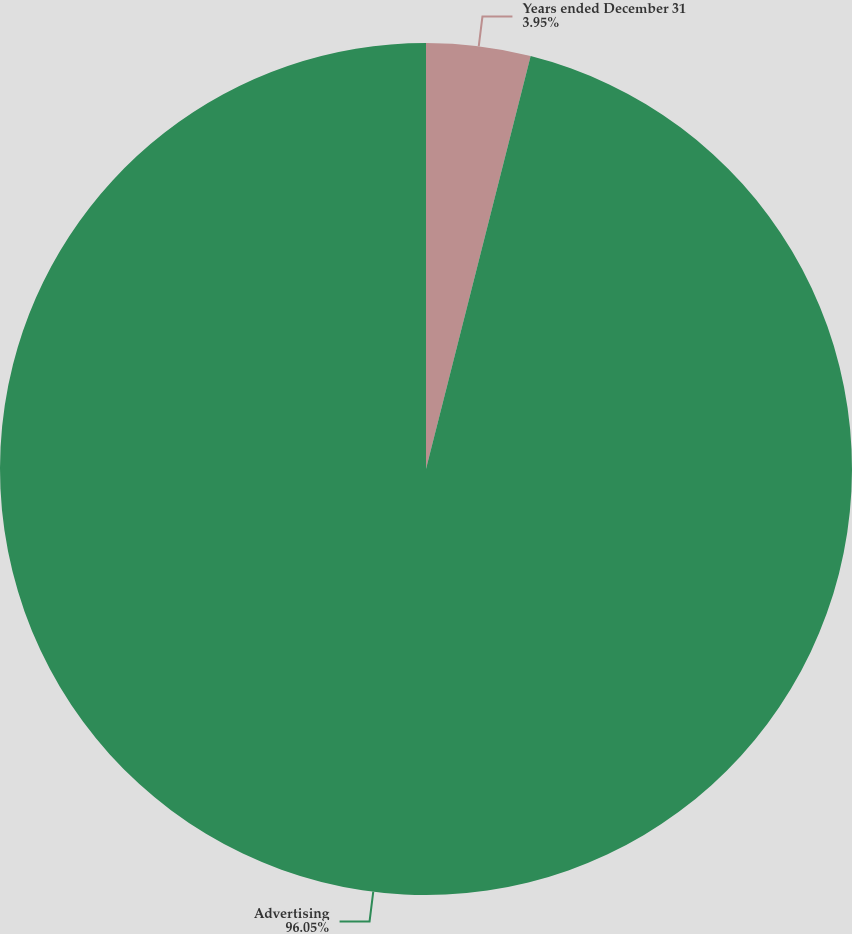Convert chart to OTSL. <chart><loc_0><loc_0><loc_500><loc_500><pie_chart><fcel>Years ended December 31<fcel>Advertising<nl><fcel>3.95%<fcel>96.05%<nl></chart> 